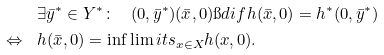Convert formula to latex. <formula><loc_0><loc_0><loc_500><loc_500>& \exists \bar { y } ^ { * } \in Y ^ { * } \colon \quad ( 0 , \bar { y } ^ { * } ) ( \bar { x } , 0 ) \i d i f h ( \bar { x } , 0 ) = h ^ { * } ( 0 , \bar { y } ^ { * } ) \\ \Leftrightarrow \quad & h ( \bar { x } , 0 ) = \inf \lim i t s _ { x \in X } h ( x , 0 ) .</formula> 